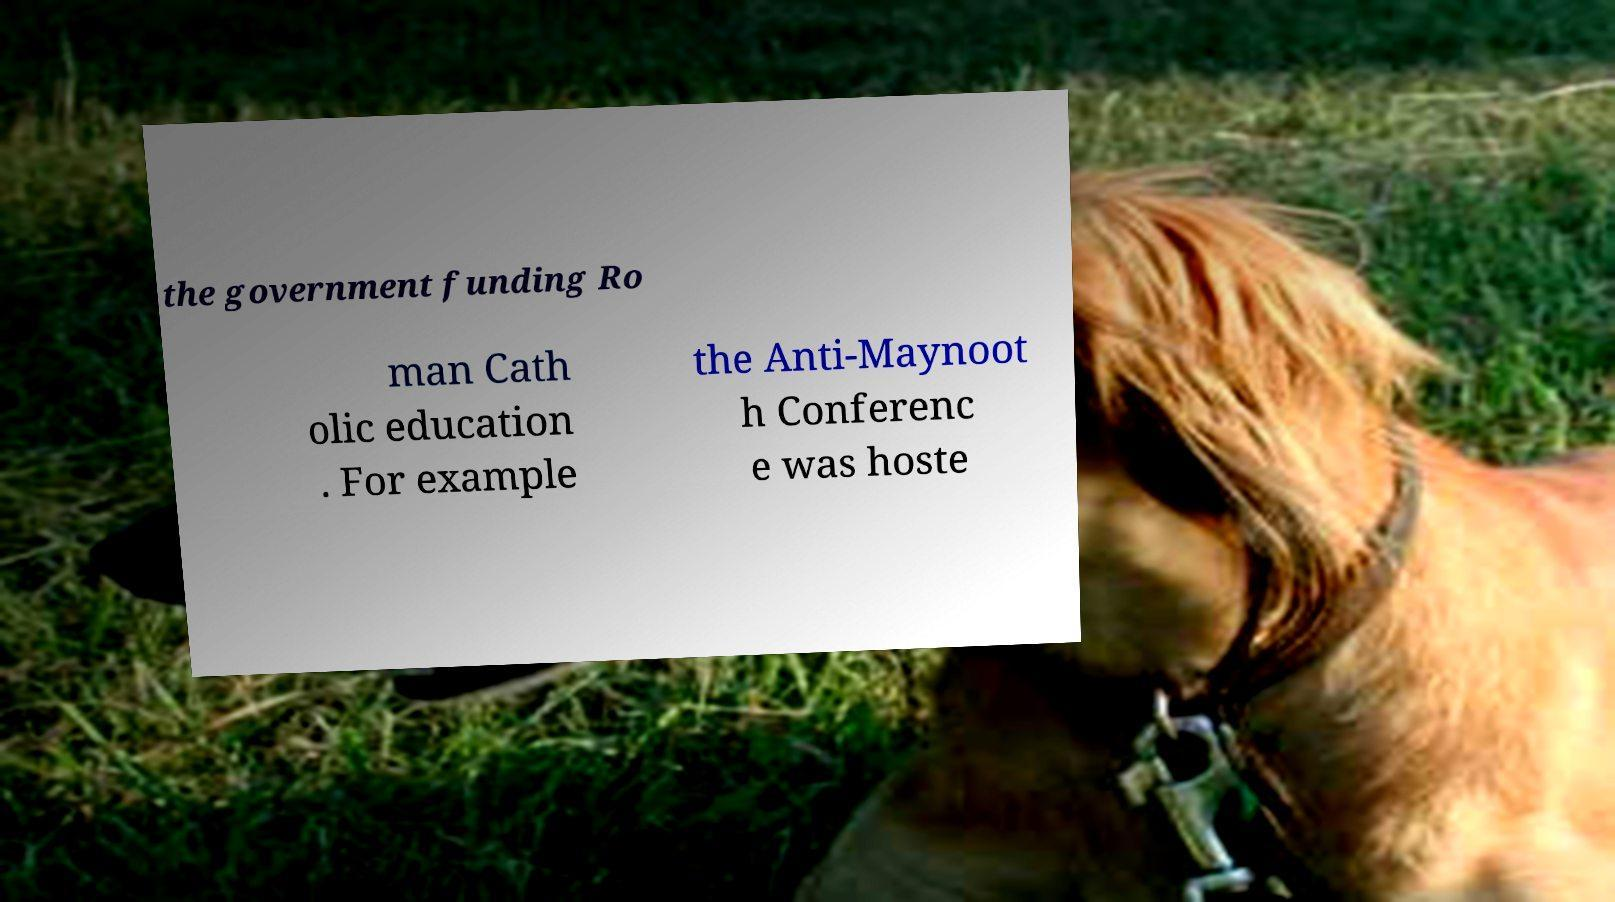Please read and relay the text visible in this image. What does it say? the government funding Ro man Cath olic education . For example the Anti-Maynoot h Conferenc e was hoste 